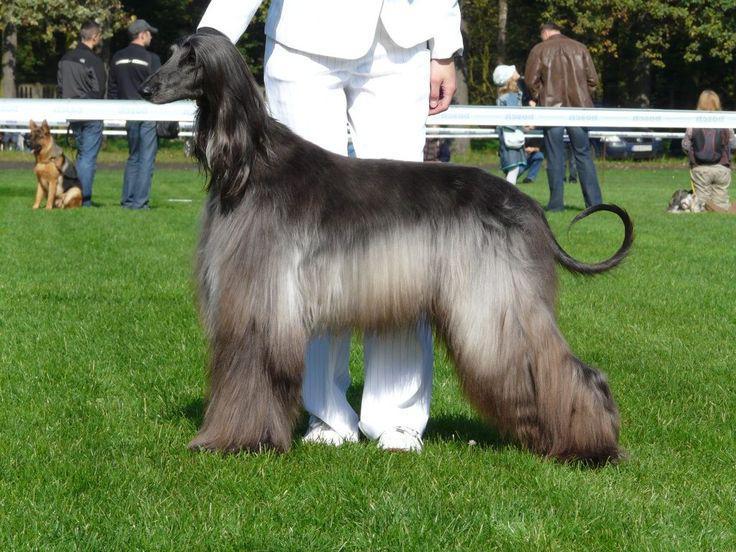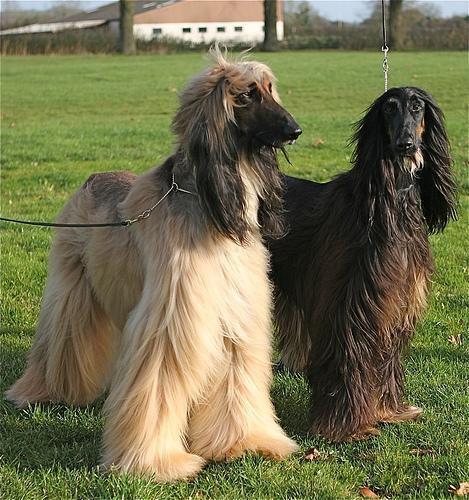The first image is the image on the left, the second image is the image on the right. Examine the images to the left and right. Is the description "There are only two dogs, and they are facing in opposite directions of each other." accurate? Answer yes or no. No. The first image is the image on the left, the second image is the image on the right. Evaluate the accuracy of this statement regarding the images: "A person in white slacks and a blazer stands directly behind a posed long-haired hound.". Is it true? Answer yes or no. Yes. 